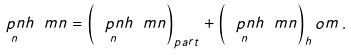<formula> <loc_0><loc_0><loc_500><loc_500>\underset { n } { \ p n { h } } \ m n = \left ( \underset { n } { \ p n { h } } \ m n \right ) _ { p a r t } + \left ( \underset { n } { \ p n { h } } \ m n \right ) _ { h } o m \, .</formula> 